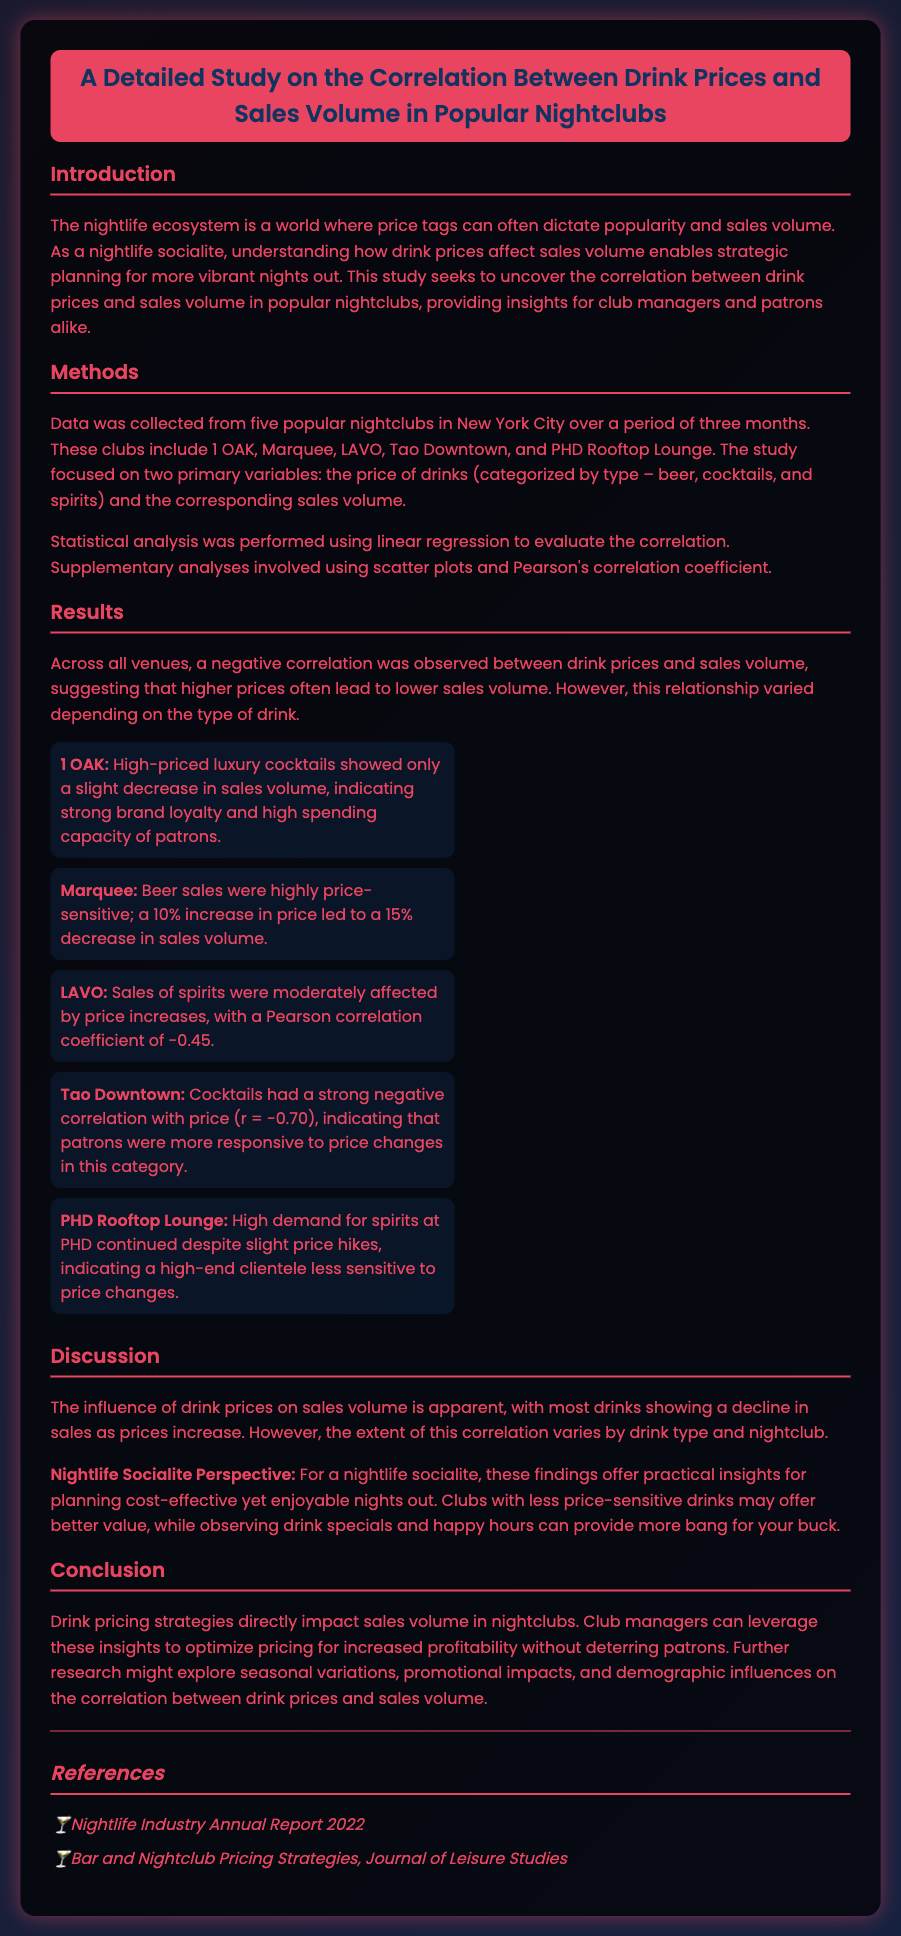What is the primary focus of the study? The study focuses on the correlation between drink prices and sales volume in popular nightclubs.
Answer: correlation between drink prices and sales volume Which nightclubs were included in the study? The document lists five specific nightclubs included in the study.
Answer: 1 OAK, Marquee, LAVO, Tao Downtown, PHD Rooftop Lounge What correlation coefficient did LAVO's spirits sales show? The document provides a specific Pearson correlation coefficient related to LAVO's spirits sales.
Answer: -0.45 How much did beer sales at Marquee decrease with a 10% price increase? The document states the percentage decrease in beer sales due to a price increase.
Answer: 15% What can nightlife socialites observe to maximize value? The document suggests a method for nightlife socialites to enhance their experience while managing costs.
Answer: drink specials and happy hours What was the correlation coefficient for cocktail sales at Tao Downtown? The document presents a specific numerical value regarding cocktail sales sensitivity to pricing.
Answer: -0.70 What does the study suggest about high demand for spirits at PHD? The document mentions insights regarding pricing impacts on spirits at PHD Rooftop Lounge.
Answer: High demand continued despite slight price hikes What do club managers need to consider according to the conclusion? The conclusion offers advice for club managers regarding pricing strategies.
Answer: optimize pricing for increased profitability 